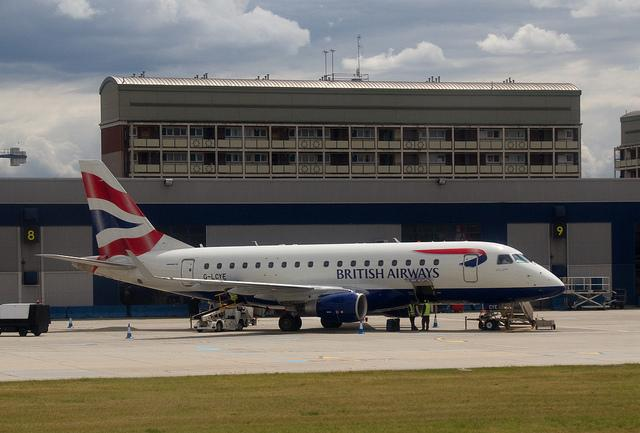What actress was born in the country where the plane comes from?

Choices:
A) jessica biel
B) margaret qualley
C) kate beckinsale
D) lucy hale kate beckinsale 